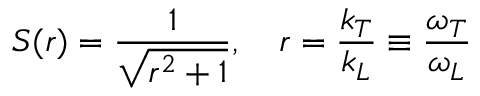<formula> <loc_0><loc_0><loc_500><loc_500>S ( r ) = \frac { 1 } { \sqrt { r ^ { 2 } + 1 } } , r = \frac { k _ { T } } { k _ { L } } \equiv \frac { \omega _ { T } } { \omega _ { L } }</formula> 